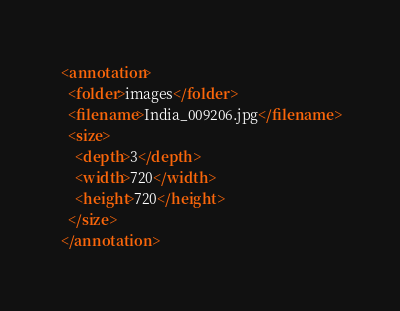<code> <loc_0><loc_0><loc_500><loc_500><_XML_><annotation>
  <folder>images</folder>
  <filename>India_009206.jpg</filename>
  <size>
    <depth>3</depth>
    <width>720</width>
    <height>720</height>
  </size>
</annotation></code> 